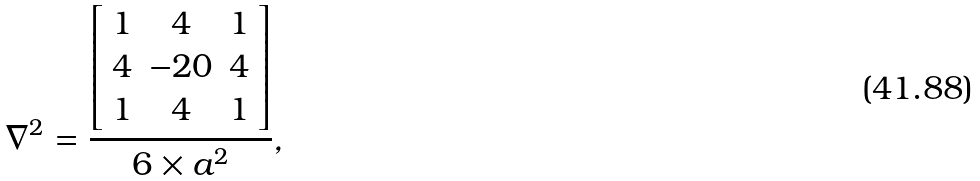<formula> <loc_0><loc_0><loc_500><loc_500>\nabla ^ { 2 } = \frac { \left [ \begin{array} { c c c c } 1 & 4 & 1 \\ 4 & - 2 0 & 4 \\ 1 & 4 & 1 \end{array} \right ] } { 6 \times a ^ { 2 } } ,</formula> 